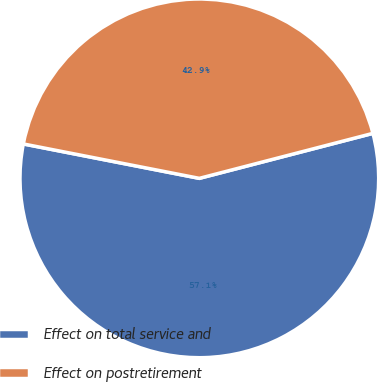Convert chart. <chart><loc_0><loc_0><loc_500><loc_500><pie_chart><fcel>Effect on total service and<fcel>Effect on postretirement<nl><fcel>57.11%<fcel>42.89%<nl></chart> 